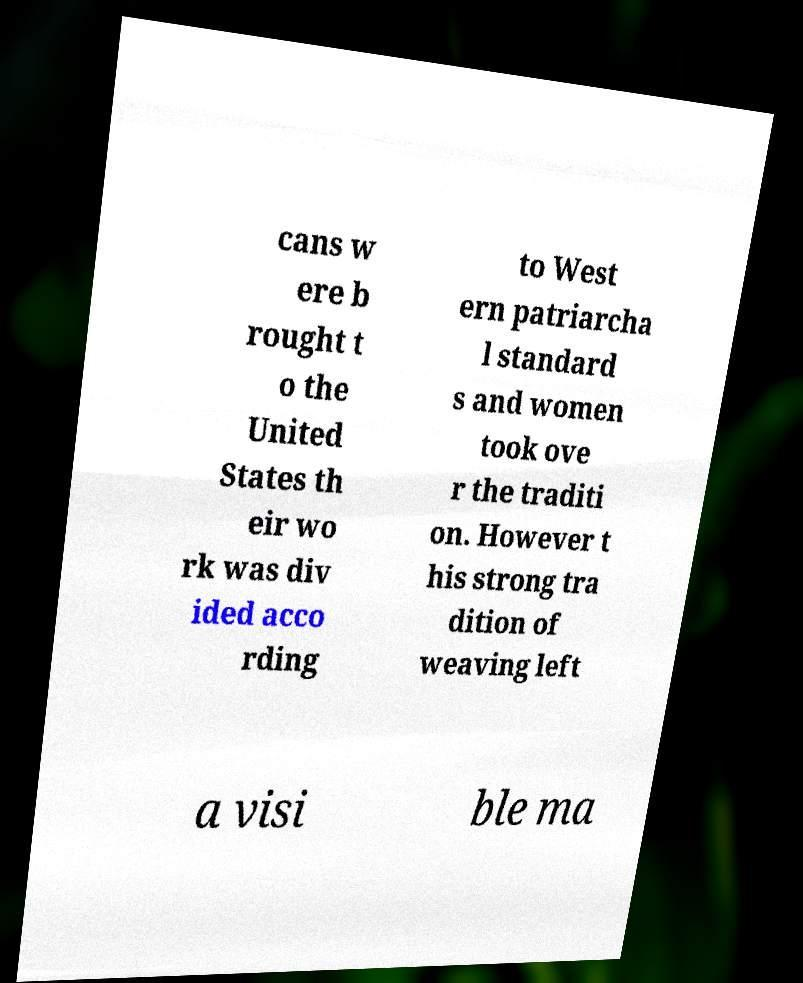There's text embedded in this image that I need extracted. Can you transcribe it verbatim? cans w ere b rought t o the United States th eir wo rk was div ided acco rding to West ern patriarcha l standard s and women took ove r the traditi on. However t his strong tra dition of weaving left a visi ble ma 